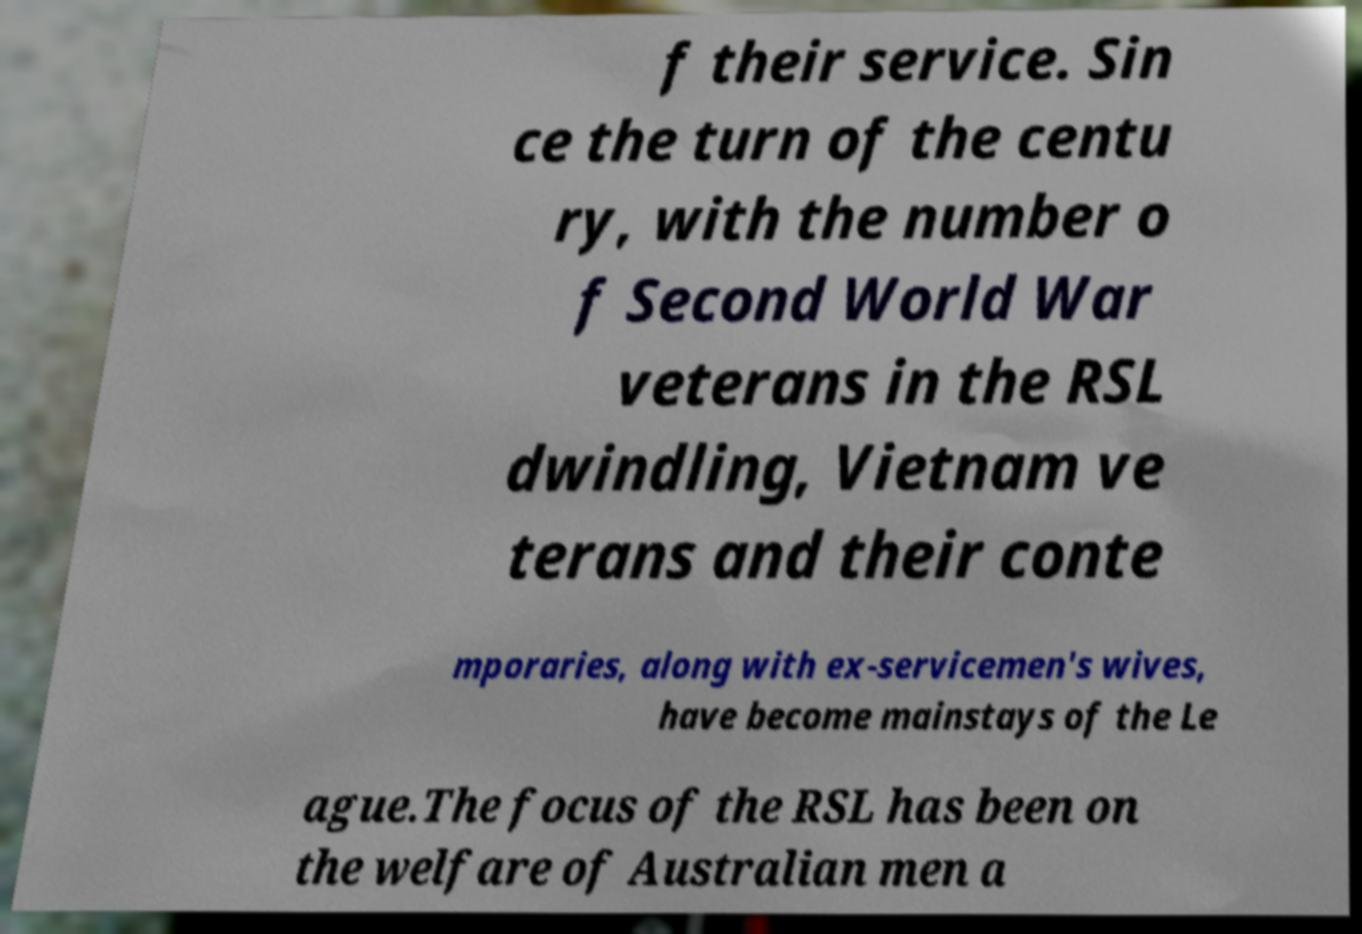Could you extract and type out the text from this image? f their service. Sin ce the turn of the centu ry, with the number o f Second World War veterans in the RSL dwindling, Vietnam ve terans and their conte mporaries, along with ex-servicemen's wives, have become mainstays of the Le ague.The focus of the RSL has been on the welfare of Australian men a 